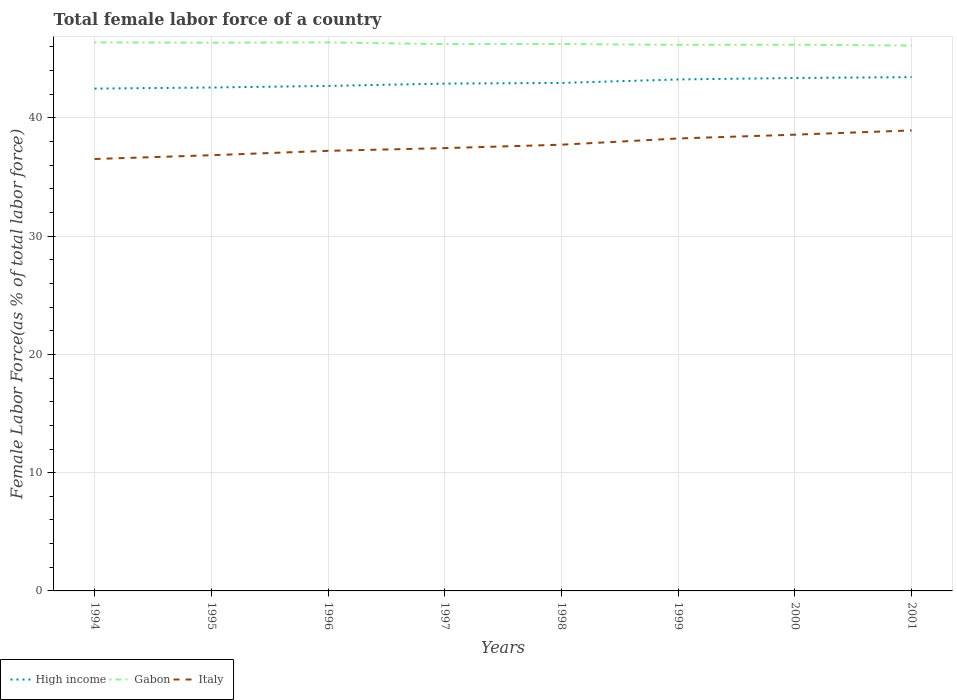How many different coloured lines are there?
Offer a terse response. 3. Across all years, what is the maximum percentage of female labor force in Italy?
Provide a succinct answer. 36.52. What is the total percentage of female labor force in Gabon in the graph?
Provide a succinct answer. 0.12. What is the difference between the highest and the second highest percentage of female labor force in High income?
Your answer should be very brief. 0.97. How many years are there in the graph?
Offer a terse response. 8. What is the difference between two consecutive major ticks on the Y-axis?
Your answer should be compact. 10. Are the values on the major ticks of Y-axis written in scientific E-notation?
Make the answer very short. No. Does the graph contain any zero values?
Provide a succinct answer. No. Does the graph contain grids?
Offer a terse response. Yes. How many legend labels are there?
Your answer should be compact. 3. How are the legend labels stacked?
Your answer should be very brief. Horizontal. What is the title of the graph?
Make the answer very short. Total female labor force of a country. Does "Pakistan" appear as one of the legend labels in the graph?
Your response must be concise. No. What is the label or title of the X-axis?
Keep it short and to the point. Years. What is the label or title of the Y-axis?
Offer a very short reply. Female Labor Force(as % of total labor force). What is the Female Labor Force(as % of total labor force) of High income in 1994?
Keep it short and to the point. 42.47. What is the Female Labor Force(as % of total labor force) of Gabon in 1994?
Ensure brevity in your answer.  46.38. What is the Female Labor Force(as % of total labor force) in Italy in 1994?
Provide a short and direct response. 36.52. What is the Female Labor Force(as % of total labor force) in High income in 1995?
Your answer should be compact. 42.57. What is the Female Labor Force(as % of total labor force) in Gabon in 1995?
Provide a short and direct response. 46.35. What is the Female Labor Force(as % of total labor force) in Italy in 1995?
Your response must be concise. 36.84. What is the Female Labor Force(as % of total labor force) in High income in 1996?
Your response must be concise. 42.7. What is the Female Labor Force(as % of total labor force) of Gabon in 1996?
Give a very brief answer. 46.38. What is the Female Labor Force(as % of total labor force) of Italy in 1996?
Make the answer very short. 37.21. What is the Female Labor Force(as % of total labor force) in High income in 1997?
Offer a very short reply. 42.9. What is the Female Labor Force(as % of total labor force) of Gabon in 1997?
Your response must be concise. 46.23. What is the Female Labor Force(as % of total labor force) in Italy in 1997?
Give a very brief answer. 37.44. What is the Female Labor Force(as % of total labor force) of High income in 1998?
Provide a succinct answer. 42.95. What is the Female Labor Force(as % of total labor force) in Gabon in 1998?
Provide a short and direct response. 46.24. What is the Female Labor Force(as % of total labor force) in Italy in 1998?
Make the answer very short. 37.73. What is the Female Labor Force(as % of total labor force) in High income in 1999?
Make the answer very short. 43.25. What is the Female Labor Force(as % of total labor force) of Gabon in 1999?
Your answer should be compact. 46.17. What is the Female Labor Force(as % of total labor force) of Italy in 1999?
Offer a terse response. 38.26. What is the Female Labor Force(as % of total labor force) in High income in 2000?
Offer a terse response. 43.37. What is the Female Labor Force(as % of total labor force) of Gabon in 2000?
Your answer should be very brief. 46.18. What is the Female Labor Force(as % of total labor force) of Italy in 2000?
Offer a very short reply. 38.58. What is the Female Labor Force(as % of total labor force) in High income in 2001?
Your response must be concise. 43.44. What is the Female Labor Force(as % of total labor force) of Gabon in 2001?
Your answer should be compact. 46.12. What is the Female Labor Force(as % of total labor force) of Italy in 2001?
Make the answer very short. 38.94. Across all years, what is the maximum Female Labor Force(as % of total labor force) in High income?
Give a very brief answer. 43.44. Across all years, what is the maximum Female Labor Force(as % of total labor force) of Gabon?
Offer a very short reply. 46.38. Across all years, what is the maximum Female Labor Force(as % of total labor force) of Italy?
Keep it short and to the point. 38.94. Across all years, what is the minimum Female Labor Force(as % of total labor force) of High income?
Ensure brevity in your answer.  42.47. Across all years, what is the minimum Female Labor Force(as % of total labor force) of Gabon?
Offer a terse response. 46.12. Across all years, what is the minimum Female Labor Force(as % of total labor force) in Italy?
Provide a short and direct response. 36.52. What is the total Female Labor Force(as % of total labor force) in High income in the graph?
Provide a succinct answer. 343.65. What is the total Female Labor Force(as % of total labor force) in Gabon in the graph?
Offer a very short reply. 370.06. What is the total Female Labor Force(as % of total labor force) of Italy in the graph?
Provide a succinct answer. 301.52. What is the difference between the Female Labor Force(as % of total labor force) of High income in 1994 and that in 1995?
Provide a short and direct response. -0.09. What is the difference between the Female Labor Force(as % of total labor force) in Gabon in 1994 and that in 1995?
Make the answer very short. 0.02. What is the difference between the Female Labor Force(as % of total labor force) of Italy in 1994 and that in 1995?
Keep it short and to the point. -0.32. What is the difference between the Female Labor Force(as % of total labor force) in High income in 1994 and that in 1996?
Make the answer very short. -0.23. What is the difference between the Female Labor Force(as % of total labor force) of Gabon in 1994 and that in 1996?
Offer a terse response. -0. What is the difference between the Female Labor Force(as % of total labor force) in Italy in 1994 and that in 1996?
Your response must be concise. -0.69. What is the difference between the Female Labor Force(as % of total labor force) of High income in 1994 and that in 1997?
Your answer should be very brief. -0.42. What is the difference between the Female Labor Force(as % of total labor force) in Gabon in 1994 and that in 1997?
Provide a succinct answer. 0.14. What is the difference between the Female Labor Force(as % of total labor force) in Italy in 1994 and that in 1997?
Your answer should be compact. -0.92. What is the difference between the Female Labor Force(as % of total labor force) of High income in 1994 and that in 1998?
Make the answer very short. -0.48. What is the difference between the Female Labor Force(as % of total labor force) in Gabon in 1994 and that in 1998?
Provide a succinct answer. 0.14. What is the difference between the Female Labor Force(as % of total labor force) in Italy in 1994 and that in 1998?
Offer a terse response. -1.21. What is the difference between the Female Labor Force(as % of total labor force) of High income in 1994 and that in 1999?
Your answer should be compact. -0.77. What is the difference between the Female Labor Force(as % of total labor force) of Gabon in 1994 and that in 1999?
Your answer should be very brief. 0.2. What is the difference between the Female Labor Force(as % of total labor force) in Italy in 1994 and that in 1999?
Provide a succinct answer. -1.74. What is the difference between the Female Labor Force(as % of total labor force) in High income in 1994 and that in 2000?
Keep it short and to the point. -0.9. What is the difference between the Female Labor Force(as % of total labor force) of Gabon in 1994 and that in 2000?
Provide a succinct answer. 0.2. What is the difference between the Female Labor Force(as % of total labor force) of Italy in 1994 and that in 2000?
Provide a succinct answer. -2.06. What is the difference between the Female Labor Force(as % of total labor force) in High income in 1994 and that in 2001?
Offer a terse response. -0.97. What is the difference between the Female Labor Force(as % of total labor force) of Gabon in 1994 and that in 2001?
Your response must be concise. 0.26. What is the difference between the Female Labor Force(as % of total labor force) in Italy in 1994 and that in 2001?
Provide a short and direct response. -2.42. What is the difference between the Female Labor Force(as % of total labor force) of High income in 1995 and that in 1996?
Keep it short and to the point. -0.14. What is the difference between the Female Labor Force(as % of total labor force) of Gabon in 1995 and that in 1996?
Ensure brevity in your answer.  -0.03. What is the difference between the Female Labor Force(as % of total labor force) in Italy in 1995 and that in 1996?
Offer a very short reply. -0.37. What is the difference between the Female Labor Force(as % of total labor force) in High income in 1995 and that in 1997?
Ensure brevity in your answer.  -0.33. What is the difference between the Female Labor Force(as % of total labor force) of Gabon in 1995 and that in 1997?
Provide a short and direct response. 0.12. What is the difference between the Female Labor Force(as % of total labor force) of Italy in 1995 and that in 1997?
Give a very brief answer. -0.6. What is the difference between the Female Labor Force(as % of total labor force) in High income in 1995 and that in 1998?
Provide a short and direct response. -0.39. What is the difference between the Female Labor Force(as % of total labor force) of Gabon in 1995 and that in 1998?
Ensure brevity in your answer.  0.11. What is the difference between the Female Labor Force(as % of total labor force) of Italy in 1995 and that in 1998?
Your response must be concise. -0.89. What is the difference between the Female Labor Force(as % of total labor force) of High income in 1995 and that in 1999?
Your answer should be compact. -0.68. What is the difference between the Female Labor Force(as % of total labor force) in Gabon in 1995 and that in 1999?
Your answer should be compact. 0.18. What is the difference between the Female Labor Force(as % of total labor force) in Italy in 1995 and that in 1999?
Your answer should be compact. -1.42. What is the difference between the Female Labor Force(as % of total labor force) in High income in 1995 and that in 2000?
Offer a terse response. -0.81. What is the difference between the Female Labor Force(as % of total labor force) of Gabon in 1995 and that in 2000?
Your answer should be compact. 0.17. What is the difference between the Female Labor Force(as % of total labor force) of Italy in 1995 and that in 2000?
Offer a terse response. -1.74. What is the difference between the Female Labor Force(as % of total labor force) of High income in 1995 and that in 2001?
Your answer should be compact. -0.88. What is the difference between the Female Labor Force(as % of total labor force) of Gabon in 1995 and that in 2001?
Your response must be concise. 0.24. What is the difference between the Female Labor Force(as % of total labor force) of Italy in 1995 and that in 2001?
Keep it short and to the point. -2.1. What is the difference between the Female Labor Force(as % of total labor force) of High income in 1996 and that in 1997?
Your response must be concise. -0.2. What is the difference between the Female Labor Force(as % of total labor force) of Gabon in 1996 and that in 1997?
Provide a succinct answer. 0.15. What is the difference between the Female Labor Force(as % of total labor force) in Italy in 1996 and that in 1997?
Your answer should be very brief. -0.23. What is the difference between the Female Labor Force(as % of total labor force) in High income in 1996 and that in 1998?
Provide a succinct answer. -0.25. What is the difference between the Female Labor Force(as % of total labor force) of Gabon in 1996 and that in 1998?
Give a very brief answer. 0.14. What is the difference between the Female Labor Force(as % of total labor force) in Italy in 1996 and that in 1998?
Keep it short and to the point. -0.52. What is the difference between the Female Labor Force(as % of total labor force) in High income in 1996 and that in 1999?
Your response must be concise. -0.55. What is the difference between the Female Labor Force(as % of total labor force) of Gabon in 1996 and that in 1999?
Ensure brevity in your answer.  0.21. What is the difference between the Female Labor Force(as % of total labor force) in Italy in 1996 and that in 1999?
Give a very brief answer. -1.05. What is the difference between the Female Labor Force(as % of total labor force) in High income in 1996 and that in 2000?
Ensure brevity in your answer.  -0.67. What is the difference between the Female Labor Force(as % of total labor force) in Gabon in 1996 and that in 2000?
Offer a terse response. 0.2. What is the difference between the Female Labor Force(as % of total labor force) in Italy in 1996 and that in 2000?
Your answer should be very brief. -1.37. What is the difference between the Female Labor Force(as % of total labor force) in High income in 1996 and that in 2001?
Ensure brevity in your answer.  -0.74. What is the difference between the Female Labor Force(as % of total labor force) of Gabon in 1996 and that in 2001?
Your answer should be very brief. 0.26. What is the difference between the Female Labor Force(as % of total labor force) of Italy in 1996 and that in 2001?
Provide a succinct answer. -1.73. What is the difference between the Female Labor Force(as % of total labor force) in High income in 1997 and that in 1998?
Make the answer very short. -0.06. What is the difference between the Female Labor Force(as % of total labor force) of Gabon in 1997 and that in 1998?
Offer a terse response. -0.01. What is the difference between the Female Labor Force(as % of total labor force) in Italy in 1997 and that in 1998?
Your answer should be compact. -0.29. What is the difference between the Female Labor Force(as % of total labor force) in High income in 1997 and that in 1999?
Offer a very short reply. -0.35. What is the difference between the Female Labor Force(as % of total labor force) of Gabon in 1997 and that in 1999?
Offer a terse response. 0.06. What is the difference between the Female Labor Force(as % of total labor force) of Italy in 1997 and that in 1999?
Give a very brief answer. -0.82. What is the difference between the Female Labor Force(as % of total labor force) of High income in 1997 and that in 2000?
Offer a terse response. -0.47. What is the difference between the Female Labor Force(as % of total labor force) of Gabon in 1997 and that in 2000?
Make the answer very short. 0.05. What is the difference between the Female Labor Force(as % of total labor force) of Italy in 1997 and that in 2000?
Offer a very short reply. -1.14. What is the difference between the Female Labor Force(as % of total labor force) of High income in 1997 and that in 2001?
Your answer should be compact. -0.55. What is the difference between the Female Labor Force(as % of total labor force) in Gabon in 1997 and that in 2001?
Your response must be concise. 0.12. What is the difference between the Female Labor Force(as % of total labor force) of Italy in 1997 and that in 2001?
Your response must be concise. -1.5. What is the difference between the Female Labor Force(as % of total labor force) of High income in 1998 and that in 1999?
Give a very brief answer. -0.3. What is the difference between the Female Labor Force(as % of total labor force) in Gabon in 1998 and that in 1999?
Ensure brevity in your answer.  0.07. What is the difference between the Female Labor Force(as % of total labor force) of Italy in 1998 and that in 1999?
Ensure brevity in your answer.  -0.53. What is the difference between the Female Labor Force(as % of total labor force) of High income in 1998 and that in 2000?
Your answer should be very brief. -0.42. What is the difference between the Female Labor Force(as % of total labor force) of Gabon in 1998 and that in 2000?
Ensure brevity in your answer.  0.06. What is the difference between the Female Labor Force(as % of total labor force) of Italy in 1998 and that in 2000?
Offer a terse response. -0.85. What is the difference between the Female Labor Force(as % of total labor force) in High income in 1998 and that in 2001?
Offer a very short reply. -0.49. What is the difference between the Female Labor Force(as % of total labor force) in Gabon in 1998 and that in 2001?
Offer a very short reply. 0.12. What is the difference between the Female Labor Force(as % of total labor force) in Italy in 1998 and that in 2001?
Provide a succinct answer. -1.21. What is the difference between the Female Labor Force(as % of total labor force) in High income in 1999 and that in 2000?
Keep it short and to the point. -0.12. What is the difference between the Female Labor Force(as % of total labor force) in Gabon in 1999 and that in 2000?
Give a very brief answer. -0.01. What is the difference between the Female Labor Force(as % of total labor force) of Italy in 1999 and that in 2000?
Your answer should be compact. -0.32. What is the difference between the Female Labor Force(as % of total labor force) of High income in 1999 and that in 2001?
Offer a very short reply. -0.2. What is the difference between the Female Labor Force(as % of total labor force) in Gabon in 1999 and that in 2001?
Provide a short and direct response. 0.06. What is the difference between the Female Labor Force(as % of total labor force) of Italy in 1999 and that in 2001?
Your answer should be very brief. -0.68. What is the difference between the Female Labor Force(as % of total labor force) of High income in 2000 and that in 2001?
Offer a terse response. -0.07. What is the difference between the Female Labor Force(as % of total labor force) of Gabon in 2000 and that in 2001?
Provide a short and direct response. 0.06. What is the difference between the Female Labor Force(as % of total labor force) of Italy in 2000 and that in 2001?
Your answer should be compact. -0.36. What is the difference between the Female Labor Force(as % of total labor force) of High income in 1994 and the Female Labor Force(as % of total labor force) of Gabon in 1995?
Offer a terse response. -3.88. What is the difference between the Female Labor Force(as % of total labor force) of High income in 1994 and the Female Labor Force(as % of total labor force) of Italy in 1995?
Your answer should be compact. 5.63. What is the difference between the Female Labor Force(as % of total labor force) in Gabon in 1994 and the Female Labor Force(as % of total labor force) in Italy in 1995?
Ensure brevity in your answer.  9.54. What is the difference between the Female Labor Force(as % of total labor force) in High income in 1994 and the Female Labor Force(as % of total labor force) in Gabon in 1996?
Offer a very short reply. -3.91. What is the difference between the Female Labor Force(as % of total labor force) of High income in 1994 and the Female Labor Force(as % of total labor force) of Italy in 1996?
Provide a short and direct response. 5.26. What is the difference between the Female Labor Force(as % of total labor force) of Gabon in 1994 and the Female Labor Force(as % of total labor force) of Italy in 1996?
Your answer should be very brief. 9.17. What is the difference between the Female Labor Force(as % of total labor force) in High income in 1994 and the Female Labor Force(as % of total labor force) in Gabon in 1997?
Provide a short and direct response. -3.76. What is the difference between the Female Labor Force(as % of total labor force) of High income in 1994 and the Female Labor Force(as % of total labor force) of Italy in 1997?
Provide a short and direct response. 5.03. What is the difference between the Female Labor Force(as % of total labor force) of Gabon in 1994 and the Female Labor Force(as % of total labor force) of Italy in 1997?
Provide a succinct answer. 8.94. What is the difference between the Female Labor Force(as % of total labor force) in High income in 1994 and the Female Labor Force(as % of total labor force) in Gabon in 1998?
Ensure brevity in your answer.  -3.77. What is the difference between the Female Labor Force(as % of total labor force) of High income in 1994 and the Female Labor Force(as % of total labor force) of Italy in 1998?
Provide a short and direct response. 4.74. What is the difference between the Female Labor Force(as % of total labor force) in Gabon in 1994 and the Female Labor Force(as % of total labor force) in Italy in 1998?
Ensure brevity in your answer.  8.65. What is the difference between the Female Labor Force(as % of total labor force) of High income in 1994 and the Female Labor Force(as % of total labor force) of Gabon in 1999?
Keep it short and to the point. -3.7. What is the difference between the Female Labor Force(as % of total labor force) in High income in 1994 and the Female Labor Force(as % of total labor force) in Italy in 1999?
Provide a succinct answer. 4.22. What is the difference between the Female Labor Force(as % of total labor force) in Gabon in 1994 and the Female Labor Force(as % of total labor force) in Italy in 1999?
Your answer should be compact. 8.12. What is the difference between the Female Labor Force(as % of total labor force) in High income in 1994 and the Female Labor Force(as % of total labor force) in Gabon in 2000?
Provide a short and direct response. -3.71. What is the difference between the Female Labor Force(as % of total labor force) in High income in 1994 and the Female Labor Force(as % of total labor force) in Italy in 2000?
Your answer should be very brief. 3.9. What is the difference between the Female Labor Force(as % of total labor force) in Gabon in 1994 and the Female Labor Force(as % of total labor force) in Italy in 2000?
Provide a short and direct response. 7.8. What is the difference between the Female Labor Force(as % of total labor force) of High income in 1994 and the Female Labor Force(as % of total labor force) of Gabon in 2001?
Keep it short and to the point. -3.64. What is the difference between the Female Labor Force(as % of total labor force) in High income in 1994 and the Female Labor Force(as % of total labor force) in Italy in 2001?
Your answer should be compact. 3.53. What is the difference between the Female Labor Force(as % of total labor force) in Gabon in 1994 and the Female Labor Force(as % of total labor force) in Italy in 2001?
Offer a terse response. 7.44. What is the difference between the Female Labor Force(as % of total labor force) in High income in 1995 and the Female Labor Force(as % of total labor force) in Gabon in 1996?
Provide a short and direct response. -3.81. What is the difference between the Female Labor Force(as % of total labor force) of High income in 1995 and the Female Labor Force(as % of total labor force) of Italy in 1996?
Your response must be concise. 5.35. What is the difference between the Female Labor Force(as % of total labor force) of Gabon in 1995 and the Female Labor Force(as % of total labor force) of Italy in 1996?
Offer a very short reply. 9.14. What is the difference between the Female Labor Force(as % of total labor force) of High income in 1995 and the Female Labor Force(as % of total labor force) of Gabon in 1997?
Your answer should be very brief. -3.67. What is the difference between the Female Labor Force(as % of total labor force) of High income in 1995 and the Female Labor Force(as % of total labor force) of Italy in 1997?
Offer a terse response. 5.12. What is the difference between the Female Labor Force(as % of total labor force) in Gabon in 1995 and the Female Labor Force(as % of total labor force) in Italy in 1997?
Offer a very short reply. 8.91. What is the difference between the Female Labor Force(as % of total labor force) in High income in 1995 and the Female Labor Force(as % of total labor force) in Gabon in 1998?
Your answer should be very brief. -3.68. What is the difference between the Female Labor Force(as % of total labor force) in High income in 1995 and the Female Labor Force(as % of total labor force) in Italy in 1998?
Make the answer very short. 4.84. What is the difference between the Female Labor Force(as % of total labor force) in Gabon in 1995 and the Female Labor Force(as % of total labor force) in Italy in 1998?
Provide a short and direct response. 8.62. What is the difference between the Female Labor Force(as % of total labor force) of High income in 1995 and the Female Labor Force(as % of total labor force) of Gabon in 1999?
Make the answer very short. -3.61. What is the difference between the Female Labor Force(as % of total labor force) of High income in 1995 and the Female Labor Force(as % of total labor force) of Italy in 1999?
Ensure brevity in your answer.  4.31. What is the difference between the Female Labor Force(as % of total labor force) in Gabon in 1995 and the Female Labor Force(as % of total labor force) in Italy in 1999?
Your answer should be very brief. 8.1. What is the difference between the Female Labor Force(as % of total labor force) in High income in 1995 and the Female Labor Force(as % of total labor force) in Gabon in 2000?
Your answer should be very brief. -3.62. What is the difference between the Female Labor Force(as % of total labor force) of High income in 1995 and the Female Labor Force(as % of total labor force) of Italy in 2000?
Ensure brevity in your answer.  3.99. What is the difference between the Female Labor Force(as % of total labor force) of Gabon in 1995 and the Female Labor Force(as % of total labor force) of Italy in 2000?
Your response must be concise. 7.78. What is the difference between the Female Labor Force(as % of total labor force) of High income in 1995 and the Female Labor Force(as % of total labor force) of Gabon in 2001?
Ensure brevity in your answer.  -3.55. What is the difference between the Female Labor Force(as % of total labor force) in High income in 1995 and the Female Labor Force(as % of total labor force) in Italy in 2001?
Make the answer very short. 3.63. What is the difference between the Female Labor Force(as % of total labor force) in Gabon in 1995 and the Female Labor Force(as % of total labor force) in Italy in 2001?
Your answer should be compact. 7.42. What is the difference between the Female Labor Force(as % of total labor force) of High income in 1996 and the Female Labor Force(as % of total labor force) of Gabon in 1997?
Offer a terse response. -3.53. What is the difference between the Female Labor Force(as % of total labor force) in High income in 1996 and the Female Labor Force(as % of total labor force) in Italy in 1997?
Keep it short and to the point. 5.26. What is the difference between the Female Labor Force(as % of total labor force) of Gabon in 1996 and the Female Labor Force(as % of total labor force) of Italy in 1997?
Your answer should be compact. 8.94. What is the difference between the Female Labor Force(as % of total labor force) of High income in 1996 and the Female Labor Force(as % of total labor force) of Gabon in 1998?
Offer a very short reply. -3.54. What is the difference between the Female Labor Force(as % of total labor force) of High income in 1996 and the Female Labor Force(as % of total labor force) of Italy in 1998?
Your answer should be compact. 4.97. What is the difference between the Female Labor Force(as % of total labor force) of Gabon in 1996 and the Female Labor Force(as % of total labor force) of Italy in 1998?
Offer a terse response. 8.65. What is the difference between the Female Labor Force(as % of total labor force) in High income in 1996 and the Female Labor Force(as % of total labor force) in Gabon in 1999?
Provide a short and direct response. -3.47. What is the difference between the Female Labor Force(as % of total labor force) in High income in 1996 and the Female Labor Force(as % of total labor force) in Italy in 1999?
Make the answer very short. 4.44. What is the difference between the Female Labor Force(as % of total labor force) in Gabon in 1996 and the Female Labor Force(as % of total labor force) in Italy in 1999?
Give a very brief answer. 8.12. What is the difference between the Female Labor Force(as % of total labor force) in High income in 1996 and the Female Labor Force(as % of total labor force) in Gabon in 2000?
Offer a terse response. -3.48. What is the difference between the Female Labor Force(as % of total labor force) in High income in 1996 and the Female Labor Force(as % of total labor force) in Italy in 2000?
Your response must be concise. 4.12. What is the difference between the Female Labor Force(as % of total labor force) of Gabon in 1996 and the Female Labor Force(as % of total labor force) of Italy in 2000?
Ensure brevity in your answer.  7.8. What is the difference between the Female Labor Force(as % of total labor force) in High income in 1996 and the Female Labor Force(as % of total labor force) in Gabon in 2001?
Provide a succinct answer. -3.42. What is the difference between the Female Labor Force(as % of total labor force) in High income in 1996 and the Female Labor Force(as % of total labor force) in Italy in 2001?
Offer a terse response. 3.76. What is the difference between the Female Labor Force(as % of total labor force) in Gabon in 1996 and the Female Labor Force(as % of total labor force) in Italy in 2001?
Offer a terse response. 7.44. What is the difference between the Female Labor Force(as % of total labor force) in High income in 1997 and the Female Labor Force(as % of total labor force) in Gabon in 1998?
Provide a succinct answer. -3.35. What is the difference between the Female Labor Force(as % of total labor force) in High income in 1997 and the Female Labor Force(as % of total labor force) in Italy in 1998?
Your answer should be very brief. 5.17. What is the difference between the Female Labor Force(as % of total labor force) of Gabon in 1997 and the Female Labor Force(as % of total labor force) of Italy in 1998?
Offer a terse response. 8.5. What is the difference between the Female Labor Force(as % of total labor force) of High income in 1997 and the Female Labor Force(as % of total labor force) of Gabon in 1999?
Provide a short and direct response. -3.28. What is the difference between the Female Labor Force(as % of total labor force) in High income in 1997 and the Female Labor Force(as % of total labor force) in Italy in 1999?
Keep it short and to the point. 4.64. What is the difference between the Female Labor Force(as % of total labor force) in Gabon in 1997 and the Female Labor Force(as % of total labor force) in Italy in 1999?
Your answer should be compact. 7.98. What is the difference between the Female Labor Force(as % of total labor force) in High income in 1997 and the Female Labor Force(as % of total labor force) in Gabon in 2000?
Provide a succinct answer. -3.29. What is the difference between the Female Labor Force(as % of total labor force) in High income in 1997 and the Female Labor Force(as % of total labor force) in Italy in 2000?
Your response must be concise. 4.32. What is the difference between the Female Labor Force(as % of total labor force) of Gabon in 1997 and the Female Labor Force(as % of total labor force) of Italy in 2000?
Give a very brief answer. 7.66. What is the difference between the Female Labor Force(as % of total labor force) in High income in 1997 and the Female Labor Force(as % of total labor force) in Gabon in 2001?
Give a very brief answer. -3.22. What is the difference between the Female Labor Force(as % of total labor force) in High income in 1997 and the Female Labor Force(as % of total labor force) in Italy in 2001?
Your answer should be compact. 3.96. What is the difference between the Female Labor Force(as % of total labor force) of Gabon in 1997 and the Female Labor Force(as % of total labor force) of Italy in 2001?
Your answer should be very brief. 7.29. What is the difference between the Female Labor Force(as % of total labor force) of High income in 1998 and the Female Labor Force(as % of total labor force) of Gabon in 1999?
Your answer should be compact. -3.22. What is the difference between the Female Labor Force(as % of total labor force) in High income in 1998 and the Female Labor Force(as % of total labor force) in Italy in 1999?
Your answer should be compact. 4.7. What is the difference between the Female Labor Force(as % of total labor force) of Gabon in 1998 and the Female Labor Force(as % of total labor force) of Italy in 1999?
Provide a short and direct response. 7.99. What is the difference between the Female Labor Force(as % of total labor force) in High income in 1998 and the Female Labor Force(as % of total labor force) in Gabon in 2000?
Your answer should be compact. -3.23. What is the difference between the Female Labor Force(as % of total labor force) of High income in 1998 and the Female Labor Force(as % of total labor force) of Italy in 2000?
Offer a very short reply. 4.37. What is the difference between the Female Labor Force(as % of total labor force) of Gabon in 1998 and the Female Labor Force(as % of total labor force) of Italy in 2000?
Make the answer very short. 7.66. What is the difference between the Female Labor Force(as % of total labor force) of High income in 1998 and the Female Labor Force(as % of total labor force) of Gabon in 2001?
Provide a short and direct response. -3.17. What is the difference between the Female Labor Force(as % of total labor force) in High income in 1998 and the Female Labor Force(as % of total labor force) in Italy in 2001?
Ensure brevity in your answer.  4.01. What is the difference between the Female Labor Force(as % of total labor force) of Gabon in 1998 and the Female Labor Force(as % of total labor force) of Italy in 2001?
Provide a succinct answer. 7.3. What is the difference between the Female Labor Force(as % of total labor force) of High income in 1999 and the Female Labor Force(as % of total labor force) of Gabon in 2000?
Offer a very short reply. -2.93. What is the difference between the Female Labor Force(as % of total labor force) of High income in 1999 and the Female Labor Force(as % of total labor force) of Italy in 2000?
Offer a terse response. 4.67. What is the difference between the Female Labor Force(as % of total labor force) in Gabon in 1999 and the Female Labor Force(as % of total labor force) in Italy in 2000?
Give a very brief answer. 7.6. What is the difference between the Female Labor Force(as % of total labor force) in High income in 1999 and the Female Labor Force(as % of total labor force) in Gabon in 2001?
Provide a short and direct response. -2.87. What is the difference between the Female Labor Force(as % of total labor force) of High income in 1999 and the Female Labor Force(as % of total labor force) of Italy in 2001?
Provide a succinct answer. 4.31. What is the difference between the Female Labor Force(as % of total labor force) in Gabon in 1999 and the Female Labor Force(as % of total labor force) in Italy in 2001?
Provide a succinct answer. 7.23. What is the difference between the Female Labor Force(as % of total labor force) of High income in 2000 and the Female Labor Force(as % of total labor force) of Gabon in 2001?
Give a very brief answer. -2.75. What is the difference between the Female Labor Force(as % of total labor force) in High income in 2000 and the Female Labor Force(as % of total labor force) in Italy in 2001?
Provide a short and direct response. 4.43. What is the difference between the Female Labor Force(as % of total labor force) of Gabon in 2000 and the Female Labor Force(as % of total labor force) of Italy in 2001?
Keep it short and to the point. 7.24. What is the average Female Labor Force(as % of total labor force) in High income per year?
Offer a terse response. 42.96. What is the average Female Labor Force(as % of total labor force) in Gabon per year?
Your response must be concise. 46.26. What is the average Female Labor Force(as % of total labor force) in Italy per year?
Offer a terse response. 37.69. In the year 1994, what is the difference between the Female Labor Force(as % of total labor force) in High income and Female Labor Force(as % of total labor force) in Gabon?
Give a very brief answer. -3.9. In the year 1994, what is the difference between the Female Labor Force(as % of total labor force) of High income and Female Labor Force(as % of total labor force) of Italy?
Your response must be concise. 5.95. In the year 1994, what is the difference between the Female Labor Force(as % of total labor force) of Gabon and Female Labor Force(as % of total labor force) of Italy?
Offer a terse response. 9.86. In the year 1995, what is the difference between the Female Labor Force(as % of total labor force) of High income and Female Labor Force(as % of total labor force) of Gabon?
Provide a short and direct response. -3.79. In the year 1995, what is the difference between the Female Labor Force(as % of total labor force) of High income and Female Labor Force(as % of total labor force) of Italy?
Offer a very short reply. 5.73. In the year 1995, what is the difference between the Female Labor Force(as % of total labor force) of Gabon and Female Labor Force(as % of total labor force) of Italy?
Your response must be concise. 9.51. In the year 1996, what is the difference between the Female Labor Force(as % of total labor force) of High income and Female Labor Force(as % of total labor force) of Gabon?
Your response must be concise. -3.68. In the year 1996, what is the difference between the Female Labor Force(as % of total labor force) in High income and Female Labor Force(as % of total labor force) in Italy?
Ensure brevity in your answer.  5.49. In the year 1996, what is the difference between the Female Labor Force(as % of total labor force) in Gabon and Female Labor Force(as % of total labor force) in Italy?
Make the answer very short. 9.17. In the year 1997, what is the difference between the Female Labor Force(as % of total labor force) of High income and Female Labor Force(as % of total labor force) of Gabon?
Give a very brief answer. -3.34. In the year 1997, what is the difference between the Female Labor Force(as % of total labor force) in High income and Female Labor Force(as % of total labor force) in Italy?
Make the answer very short. 5.46. In the year 1997, what is the difference between the Female Labor Force(as % of total labor force) in Gabon and Female Labor Force(as % of total labor force) in Italy?
Offer a very short reply. 8.79. In the year 1998, what is the difference between the Female Labor Force(as % of total labor force) in High income and Female Labor Force(as % of total labor force) in Gabon?
Offer a terse response. -3.29. In the year 1998, what is the difference between the Female Labor Force(as % of total labor force) in High income and Female Labor Force(as % of total labor force) in Italy?
Provide a short and direct response. 5.22. In the year 1998, what is the difference between the Female Labor Force(as % of total labor force) of Gabon and Female Labor Force(as % of total labor force) of Italy?
Provide a short and direct response. 8.51. In the year 1999, what is the difference between the Female Labor Force(as % of total labor force) in High income and Female Labor Force(as % of total labor force) in Gabon?
Make the answer very short. -2.93. In the year 1999, what is the difference between the Female Labor Force(as % of total labor force) of High income and Female Labor Force(as % of total labor force) of Italy?
Your response must be concise. 4.99. In the year 1999, what is the difference between the Female Labor Force(as % of total labor force) in Gabon and Female Labor Force(as % of total labor force) in Italy?
Offer a very short reply. 7.92. In the year 2000, what is the difference between the Female Labor Force(as % of total labor force) of High income and Female Labor Force(as % of total labor force) of Gabon?
Provide a succinct answer. -2.81. In the year 2000, what is the difference between the Female Labor Force(as % of total labor force) in High income and Female Labor Force(as % of total labor force) in Italy?
Your response must be concise. 4.79. In the year 2000, what is the difference between the Female Labor Force(as % of total labor force) in Gabon and Female Labor Force(as % of total labor force) in Italy?
Provide a succinct answer. 7.6. In the year 2001, what is the difference between the Female Labor Force(as % of total labor force) in High income and Female Labor Force(as % of total labor force) in Gabon?
Give a very brief answer. -2.67. In the year 2001, what is the difference between the Female Labor Force(as % of total labor force) in High income and Female Labor Force(as % of total labor force) in Italy?
Ensure brevity in your answer.  4.5. In the year 2001, what is the difference between the Female Labor Force(as % of total labor force) in Gabon and Female Labor Force(as % of total labor force) in Italy?
Your response must be concise. 7.18. What is the ratio of the Female Labor Force(as % of total labor force) in Gabon in 1994 to that in 1995?
Offer a terse response. 1. What is the ratio of the Female Labor Force(as % of total labor force) of Italy in 1994 to that in 1996?
Your response must be concise. 0.98. What is the ratio of the Female Labor Force(as % of total labor force) of High income in 1994 to that in 1997?
Ensure brevity in your answer.  0.99. What is the ratio of the Female Labor Force(as % of total labor force) of Gabon in 1994 to that in 1997?
Your answer should be very brief. 1. What is the ratio of the Female Labor Force(as % of total labor force) of Italy in 1994 to that in 1997?
Keep it short and to the point. 0.98. What is the ratio of the Female Labor Force(as % of total labor force) in High income in 1994 to that in 1998?
Provide a succinct answer. 0.99. What is the ratio of the Female Labor Force(as % of total labor force) of High income in 1994 to that in 1999?
Offer a very short reply. 0.98. What is the ratio of the Female Labor Force(as % of total labor force) in Italy in 1994 to that in 1999?
Keep it short and to the point. 0.95. What is the ratio of the Female Labor Force(as % of total labor force) in High income in 1994 to that in 2000?
Your answer should be compact. 0.98. What is the ratio of the Female Labor Force(as % of total labor force) in Gabon in 1994 to that in 2000?
Give a very brief answer. 1. What is the ratio of the Female Labor Force(as % of total labor force) in Italy in 1994 to that in 2000?
Offer a terse response. 0.95. What is the ratio of the Female Labor Force(as % of total labor force) of High income in 1994 to that in 2001?
Provide a succinct answer. 0.98. What is the ratio of the Female Labor Force(as % of total labor force) of Gabon in 1994 to that in 2001?
Provide a succinct answer. 1.01. What is the ratio of the Female Labor Force(as % of total labor force) of Italy in 1994 to that in 2001?
Ensure brevity in your answer.  0.94. What is the ratio of the Female Labor Force(as % of total labor force) in High income in 1995 to that in 1997?
Give a very brief answer. 0.99. What is the ratio of the Female Labor Force(as % of total labor force) in Gabon in 1995 to that in 1997?
Make the answer very short. 1. What is the ratio of the Female Labor Force(as % of total labor force) of Italy in 1995 to that in 1997?
Your answer should be very brief. 0.98. What is the ratio of the Female Labor Force(as % of total labor force) in Gabon in 1995 to that in 1998?
Provide a succinct answer. 1. What is the ratio of the Female Labor Force(as % of total labor force) of Italy in 1995 to that in 1998?
Provide a succinct answer. 0.98. What is the ratio of the Female Labor Force(as % of total labor force) of High income in 1995 to that in 1999?
Keep it short and to the point. 0.98. What is the ratio of the Female Labor Force(as % of total labor force) of Italy in 1995 to that in 1999?
Make the answer very short. 0.96. What is the ratio of the Female Labor Force(as % of total labor force) of High income in 1995 to that in 2000?
Offer a terse response. 0.98. What is the ratio of the Female Labor Force(as % of total labor force) of Italy in 1995 to that in 2000?
Make the answer very short. 0.95. What is the ratio of the Female Labor Force(as % of total labor force) in High income in 1995 to that in 2001?
Your answer should be very brief. 0.98. What is the ratio of the Female Labor Force(as % of total labor force) in Gabon in 1995 to that in 2001?
Provide a succinct answer. 1.01. What is the ratio of the Female Labor Force(as % of total labor force) of Italy in 1995 to that in 2001?
Your answer should be compact. 0.95. What is the ratio of the Female Labor Force(as % of total labor force) of High income in 1996 to that in 1997?
Offer a very short reply. 1. What is the ratio of the Female Labor Force(as % of total labor force) of High income in 1996 to that in 1998?
Ensure brevity in your answer.  0.99. What is the ratio of the Female Labor Force(as % of total labor force) in Italy in 1996 to that in 1998?
Ensure brevity in your answer.  0.99. What is the ratio of the Female Labor Force(as % of total labor force) of High income in 1996 to that in 1999?
Give a very brief answer. 0.99. What is the ratio of the Female Labor Force(as % of total labor force) of Gabon in 1996 to that in 1999?
Provide a succinct answer. 1. What is the ratio of the Female Labor Force(as % of total labor force) of Italy in 1996 to that in 1999?
Your response must be concise. 0.97. What is the ratio of the Female Labor Force(as % of total labor force) of High income in 1996 to that in 2000?
Your answer should be compact. 0.98. What is the ratio of the Female Labor Force(as % of total labor force) of Italy in 1996 to that in 2000?
Provide a succinct answer. 0.96. What is the ratio of the Female Labor Force(as % of total labor force) in High income in 1996 to that in 2001?
Keep it short and to the point. 0.98. What is the ratio of the Female Labor Force(as % of total labor force) of Italy in 1996 to that in 2001?
Provide a succinct answer. 0.96. What is the ratio of the Female Labor Force(as % of total labor force) of High income in 1997 to that in 1998?
Offer a terse response. 1. What is the ratio of the Female Labor Force(as % of total labor force) in High income in 1997 to that in 1999?
Your response must be concise. 0.99. What is the ratio of the Female Labor Force(as % of total labor force) of Italy in 1997 to that in 1999?
Your answer should be very brief. 0.98. What is the ratio of the Female Labor Force(as % of total labor force) of High income in 1997 to that in 2000?
Your response must be concise. 0.99. What is the ratio of the Female Labor Force(as % of total labor force) in Gabon in 1997 to that in 2000?
Your answer should be compact. 1. What is the ratio of the Female Labor Force(as % of total labor force) in Italy in 1997 to that in 2000?
Provide a short and direct response. 0.97. What is the ratio of the Female Labor Force(as % of total labor force) in High income in 1997 to that in 2001?
Your answer should be very brief. 0.99. What is the ratio of the Female Labor Force(as % of total labor force) in Gabon in 1997 to that in 2001?
Your answer should be very brief. 1. What is the ratio of the Female Labor Force(as % of total labor force) in Italy in 1997 to that in 2001?
Make the answer very short. 0.96. What is the ratio of the Female Labor Force(as % of total labor force) of Italy in 1998 to that in 1999?
Offer a very short reply. 0.99. What is the ratio of the Female Labor Force(as % of total labor force) in High income in 1998 to that in 2000?
Provide a succinct answer. 0.99. What is the ratio of the Female Labor Force(as % of total labor force) of Gabon in 1998 to that in 2000?
Provide a succinct answer. 1. What is the ratio of the Female Labor Force(as % of total labor force) in Italy in 1998 to that in 2000?
Ensure brevity in your answer.  0.98. What is the ratio of the Female Labor Force(as % of total labor force) of High income in 1998 to that in 2001?
Make the answer very short. 0.99. What is the ratio of the Female Labor Force(as % of total labor force) in Gabon in 1998 to that in 2001?
Your answer should be very brief. 1. What is the ratio of the Female Labor Force(as % of total labor force) of Italy in 1998 to that in 2001?
Provide a short and direct response. 0.97. What is the ratio of the Female Labor Force(as % of total labor force) in High income in 1999 to that in 2000?
Offer a very short reply. 1. What is the ratio of the Female Labor Force(as % of total labor force) of High income in 1999 to that in 2001?
Your answer should be very brief. 1. What is the ratio of the Female Labor Force(as % of total labor force) of Italy in 1999 to that in 2001?
Give a very brief answer. 0.98. What is the ratio of the Female Labor Force(as % of total labor force) in Italy in 2000 to that in 2001?
Your response must be concise. 0.99. What is the difference between the highest and the second highest Female Labor Force(as % of total labor force) in High income?
Your response must be concise. 0.07. What is the difference between the highest and the second highest Female Labor Force(as % of total labor force) of Gabon?
Your response must be concise. 0. What is the difference between the highest and the second highest Female Labor Force(as % of total labor force) in Italy?
Keep it short and to the point. 0.36. What is the difference between the highest and the lowest Female Labor Force(as % of total labor force) in High income?
Offer a terse response. 0.97. What is the difference between the highest and the lowest Female Labor Force(as % of total labor force) of Gabon?
Provide a short and direct response. 0.26. What is the difference between the highest and the lowest Female Labor Force(as % of total labor force) of Italy?
Your answer should be very brief. 2.42. 